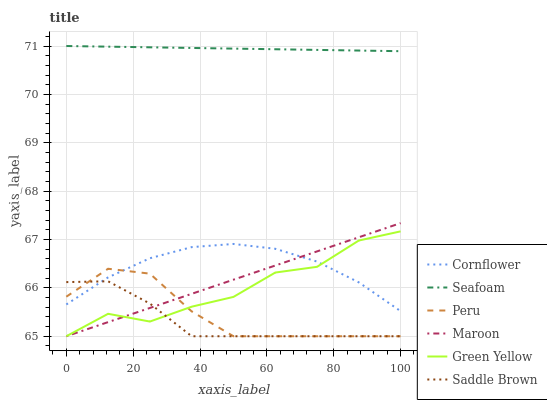Does Maroon have the minimum area under the curve?
Answer yes or no. No. Does Maroon have the maximum area under the curve?
Answer yes or no. No. Is Maroon the smoothest?
Answer yes or no. No. Is Maroon the roughest?
Answer yes or no. No. Does Seafoam have the lowest value?
Answer yes or no. No. Does Maroon have the highest value?
Answer yes or no. No. Is Cornflower less than Seafoam?
Answer yes or no. Yes. Is Seafoam greater than Maroon?
Answer yes or no. Yes. Does Cornflower intersect Seafoam?
Answer yes or no. No. 